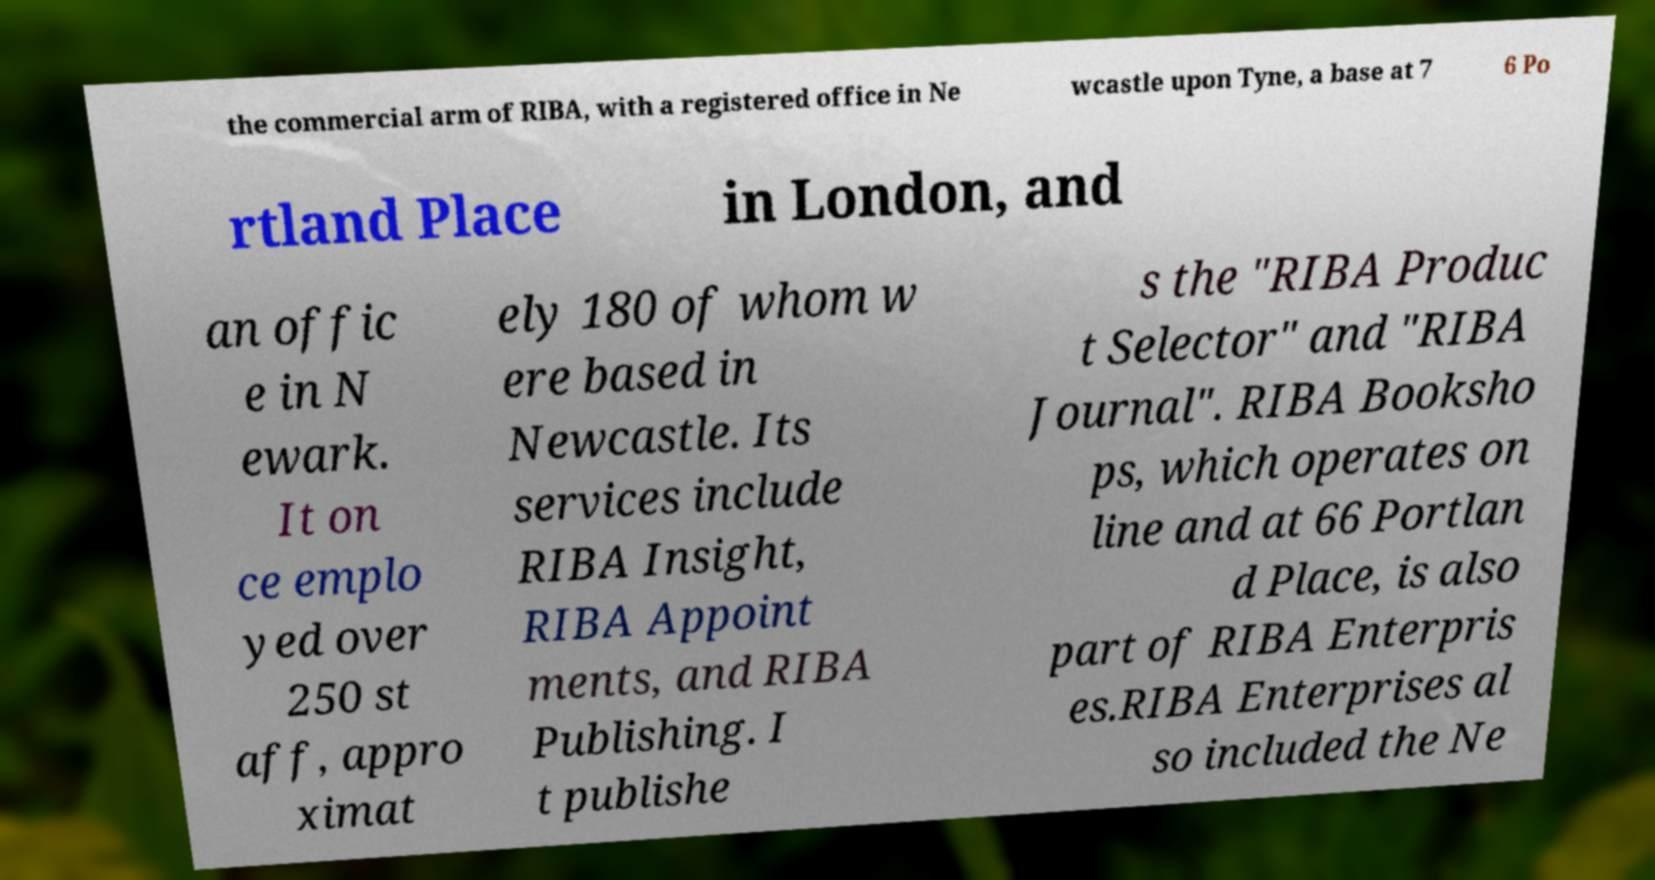Can you accurately transcribe the text from the provided image for me? the commercial arm of RIBA, with a registered office in Ne wcastle upon Tyne, a base at 7 6 Po rtland Place in London, and an offic e in N ewark. It on ce emplo yed over 250 st aff, appro ximat ely 180 of whom w ere based in Newcastle. Its services include RIBA Insight, RIBA Appoint ments, and RIBA Publishing. I t publishe s the "RIBA Produc t Selector" and "RIBA Journal". RIBA Booksho ps, which operates on line and at 66 Portlan d Place, is also part of RIBA Enterpris es.RIBA Enterprises al so included the Ne 